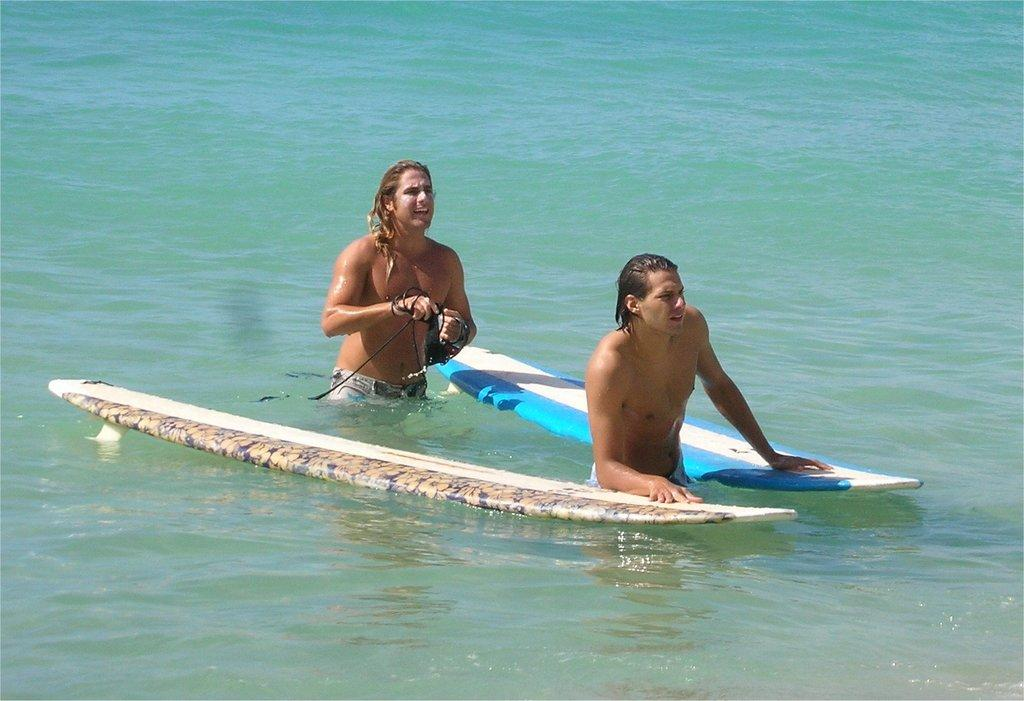How many people are in the image? There are two people in the image. What is one person doing in the image? One person has placed their hands on a diving device. What is the other person holding in their hand? The other person is holding a thread in their hand. How many children are present in the image? There is no information about children in the image, so we cannot determine their presence. 